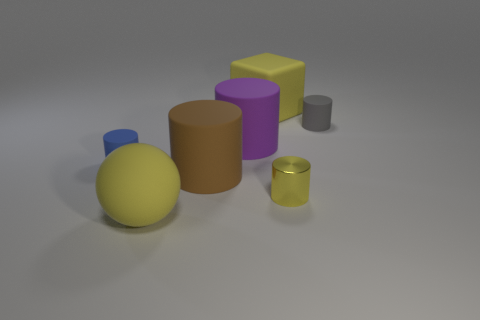Subtract all yellow metal cylinders. How many cylinders are left? 4 Subtract all gray cylinders. How many cylinders are left? 4 Add 3 matte things. How many objects exist? 10 Subtract all cyan cylinders. Subtract all blue cubes. How many cylinders are left? 5 Subtract all cylinders. How many objects are left? 2 Add 2 big balls. How many big balls are left? 3 Add 6 tiny red rubber blocks. How many tiny red rubber blocks exist? 6 Subtract 0 gray balls. How many objects are left? 7 Subtract all big purple rubber cylinders. Subtract all small green matte cubes. How many objects are left? 6 